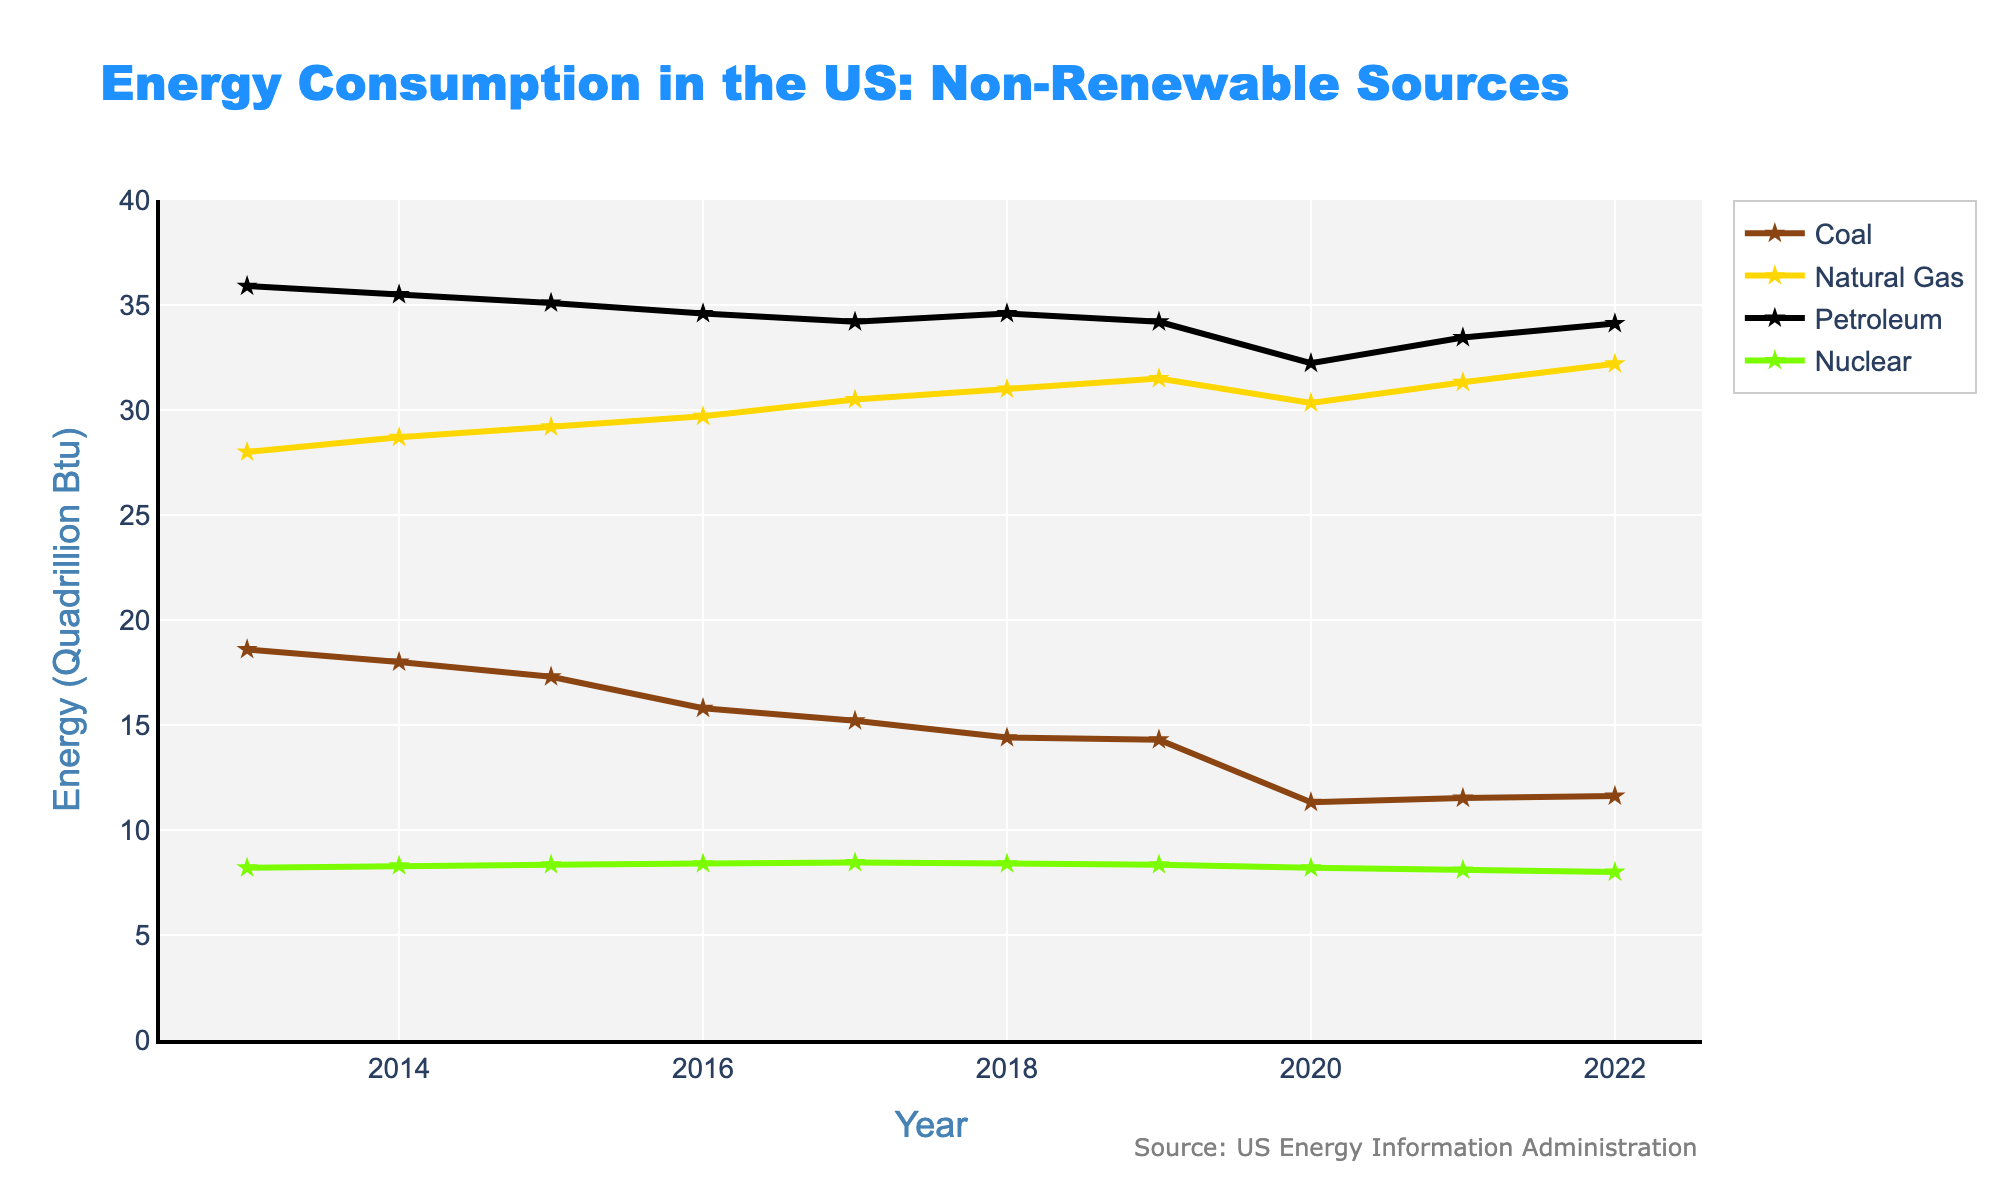What is the total non-renewable energy consumption in 2013? Look at the "Total Non-Renewable" data point for the year 2013 in the plot.
Answer: 90.70 Quadrillion Btu Which year had the lowest coal consumption? Look at the plot for the line representing Coal and find the data point with the lowest value.
Answer: 2020 What is the trend in natural gas consumption from 2013 to 2022? Observe the line representing Natural Gas in the plot over the years and describe whether it generally increases, decreases, or remains stable.
Answer: Increasing How much more petroleum was consumed in 2013 compared to 2022? Subtract the value of Petroleum consumption in 2022 from that in 2013.
Answer: 1.78 Quadrillion Btu In which year did the total non-renewable energy consumption fall below 85 Quadrillion Btu for the first time? Find the first data point in the Total Non-Renewable line that is less than 85 Quadrillion Btu.
Answer: 2020 Compare the difference between coal and nuclear energy consumption in 2020. Observe the values for Coal and Nuclear in 2020 and subtract the nuclear value from the coal value.
Answer: 3.12 Quadrillion Btu Which energy source had the highest consumption in 2021? Look at the values for each energy source in 2021 and identify the highest one.
Answer: Petroleum What is the general trend observed for total non-renewable energy consumption over the past decade? Observe the general direction of the Total Non-Renewable line from 2013 to 2022.
Answer: Decreasing What is the average consumption of nuclear energy over the past decade? Sum the values for Nuclear from 2013 to 2022 and divide by the number of years (10). (8.20 + 8.30 + 8.35 + 8.40 + 8.45 + 8.40 + 8.35 + 8.20 + 8.10 + 8.00)/10 = 8.275
Answer: 8.275 Quadrillion Btu Which year saw the smallest change in total non-renewable energy consumption compared to the previous year? Find the year-to-year changes in the Total Non-Renewable line and identify the smallest absolute change.
Answer: 2017 